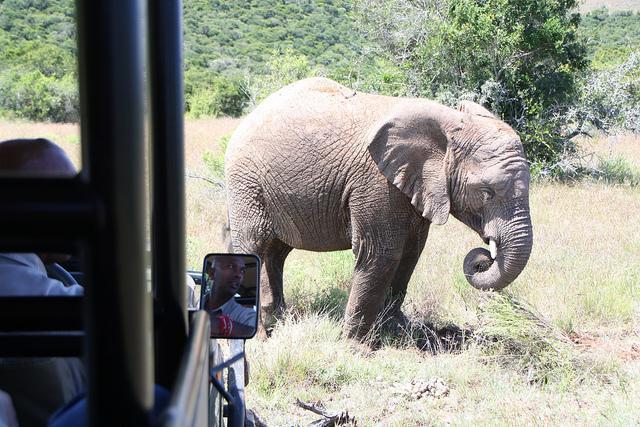How many people are there?
Give a very brief answer. 2. 